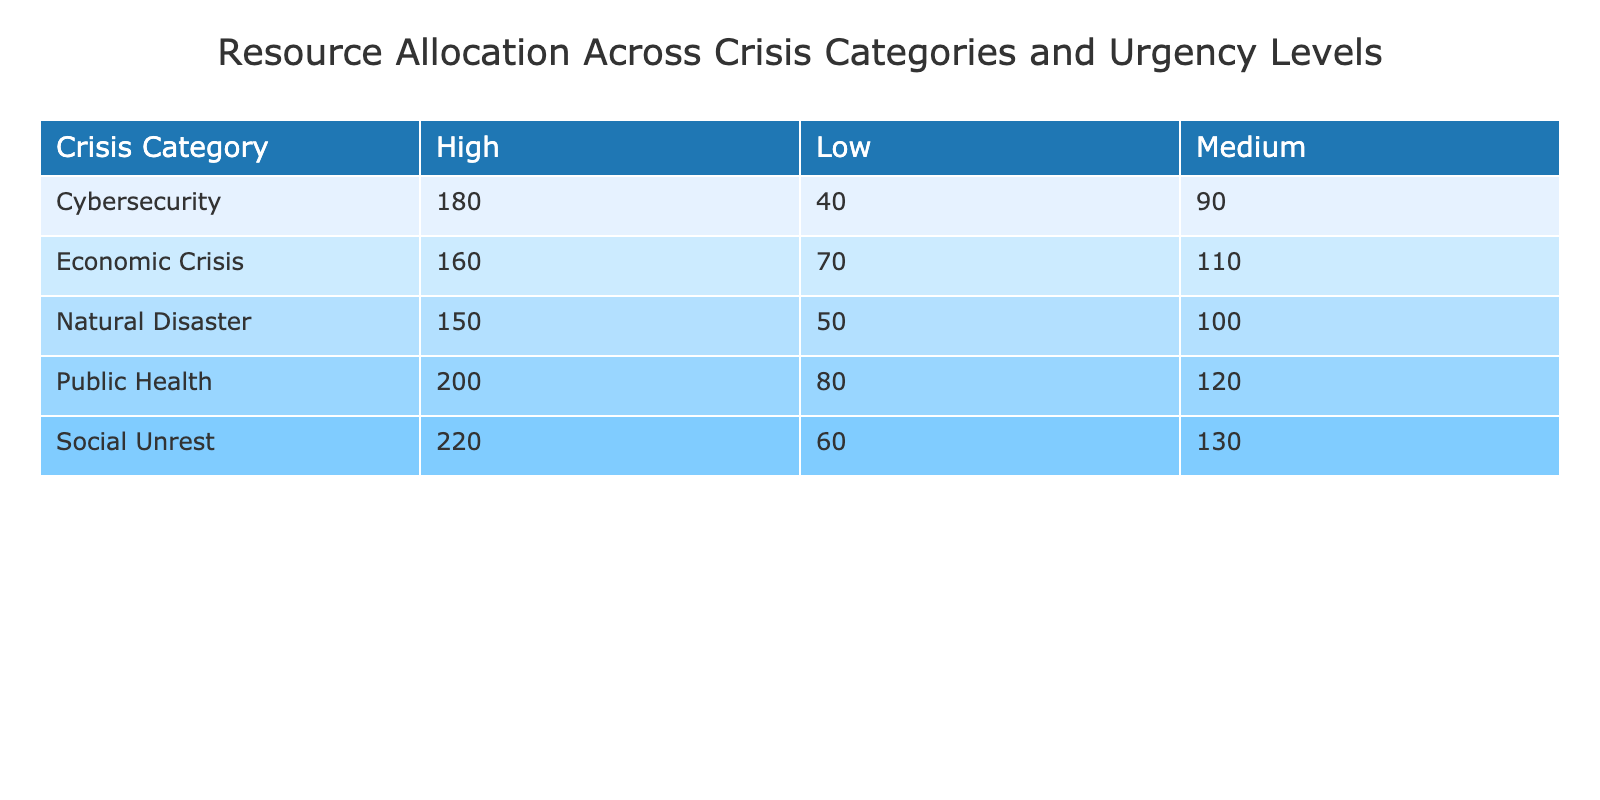What is the resource allocation for Social Unrest at a High urgency level? The table shows that under the crisis category of 'Social Unrest' and at a 'High' urgency level, the resource allocation is 220.
Answer: 220 What is the total resource allocation for Public Health across all urgency levels? To find the total resource allocation for 'Public Health', add the values across all urgency levels: 200 (High) + 120 (Medium) + 80 (Low) = 400.
Answer: 400 Is the resource allocation for Cybersecurity at a Medium urgency level greater than that for Economic Crisis at the same urgency level? According to the table, Cybersecurity has a resource allocation of 90 at Medium urgency, while Economic Crisis has a resource allocation of 110 at Medium urgency. Since 90 < 110, the statement is false.
Answer: No What is the average resource allocation for Natural Disasters? The resource allocations for Natural Disasters are 150 (High), 100 (Medium), and 50 (Low). The average is calculated by summing these values (150 + 100 + 50 = 300) and dividing by the number of urgency levels (3). Therefore, the average resource allocation is 300 / 3 = 100.
Answer: 100 What is the difference in resource allocation between the High urgency levels of Social Unrest and Economic Crisis? For Social Unrest, the resource allocation at High urgency is 220, while for Economic Crisis, it is 160. The difference is calculated by subtracting the latter from the former: 220 - 160 = 60.
Answer: 60 Is the total resource allocation for Low urgency levels greater than 300? First, sum the resource allocations for all crisis categories at the Low urgency level: 50 (Natural Disaster) + 80 (Public Health) + 40 (Cybersecurity) + 70 (Economic Crisis) + 60 (Social Unrest) = 300. Since 300 is not greater than 300, the answer is false.
Answer: No What is the highest resource allocation recorded in the table? By reviewing each crisis category under High urgency, Social Unrest has the highest allocation of 220, which is greater than other categories. No other categories exceed this amount, confirming it is the highest.
Answer: 220 How does the resource allocation for Natural Disaster at Medium urgency compare to that of Cybersecurity at the same level? For Natural Disaster, the Medium urgency allocation is 100, whereas for Cybersecurity, it is 90. Since 100 is greater than 90, it can be concluded that Natural Disaster has a higher allocation.
Answer: Higher What is the total resource allocation across all categories for High urgency levels? The resource allocations for High urgency levels are: 150 (Natural Disaster) + 200 (Public Health) + 180 (Cybersecurity) + 160 (Economic Crisis) + 220 (Social Unrest) = 1,110. Therefore, the total across all categories for High urgency levels is 1,110.
Answer: 1110 